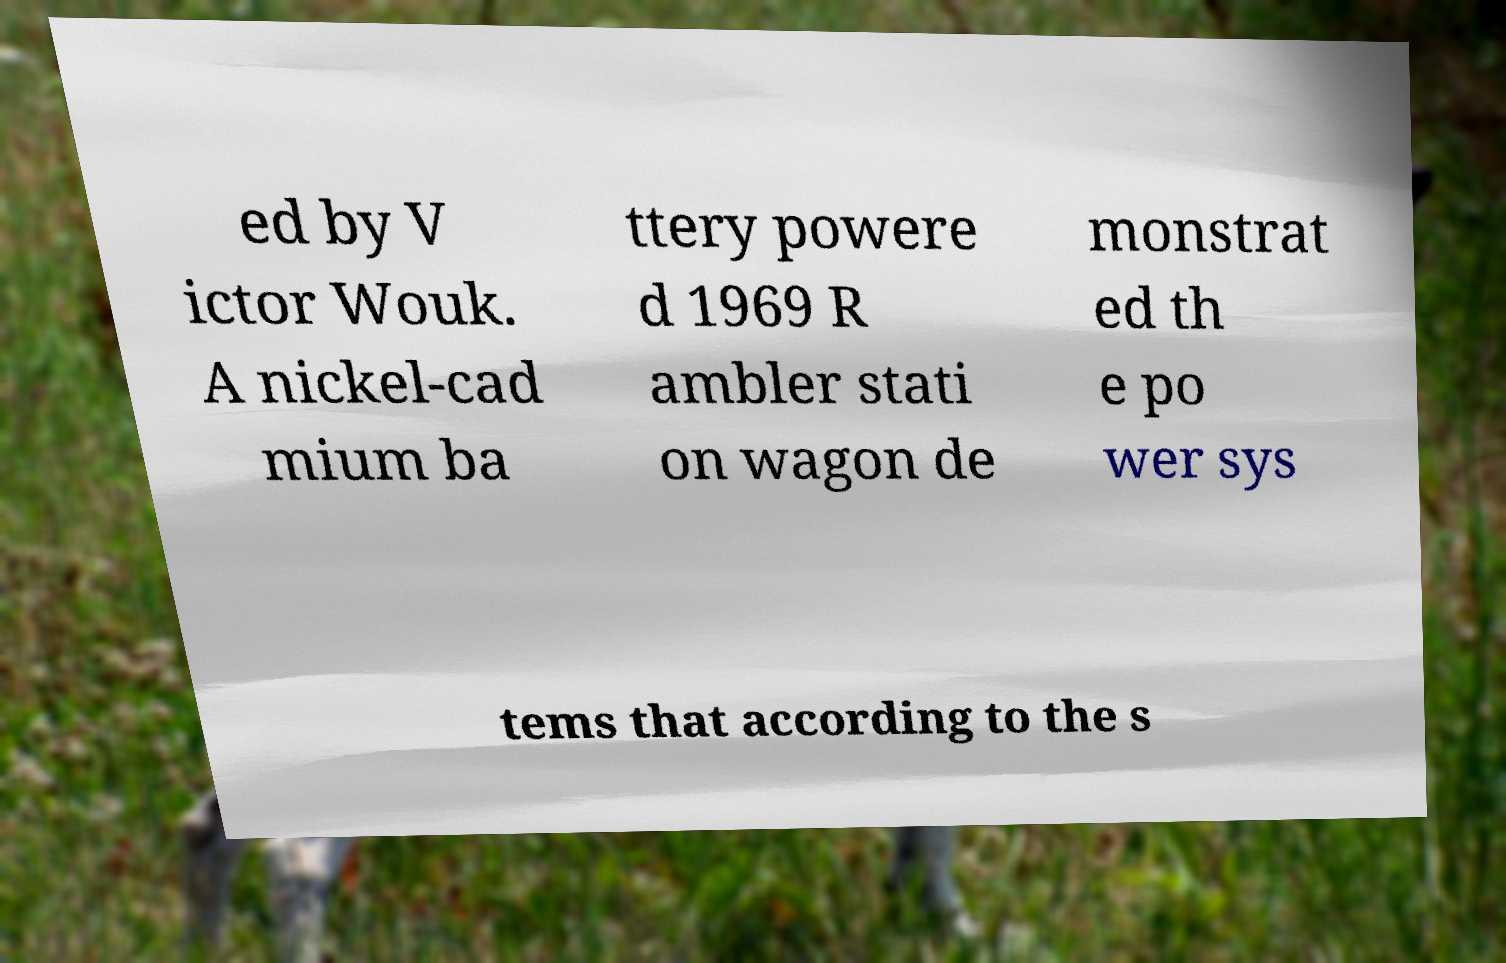For documentation purposes, I need the text within this image transcribed. Could you provide that? ed by V ictor Wouk. A nickel-cad mium ba ttery powere d 1969 R ambler stati on wagon de monstrat ed th e po wer sys tems that according to the s 